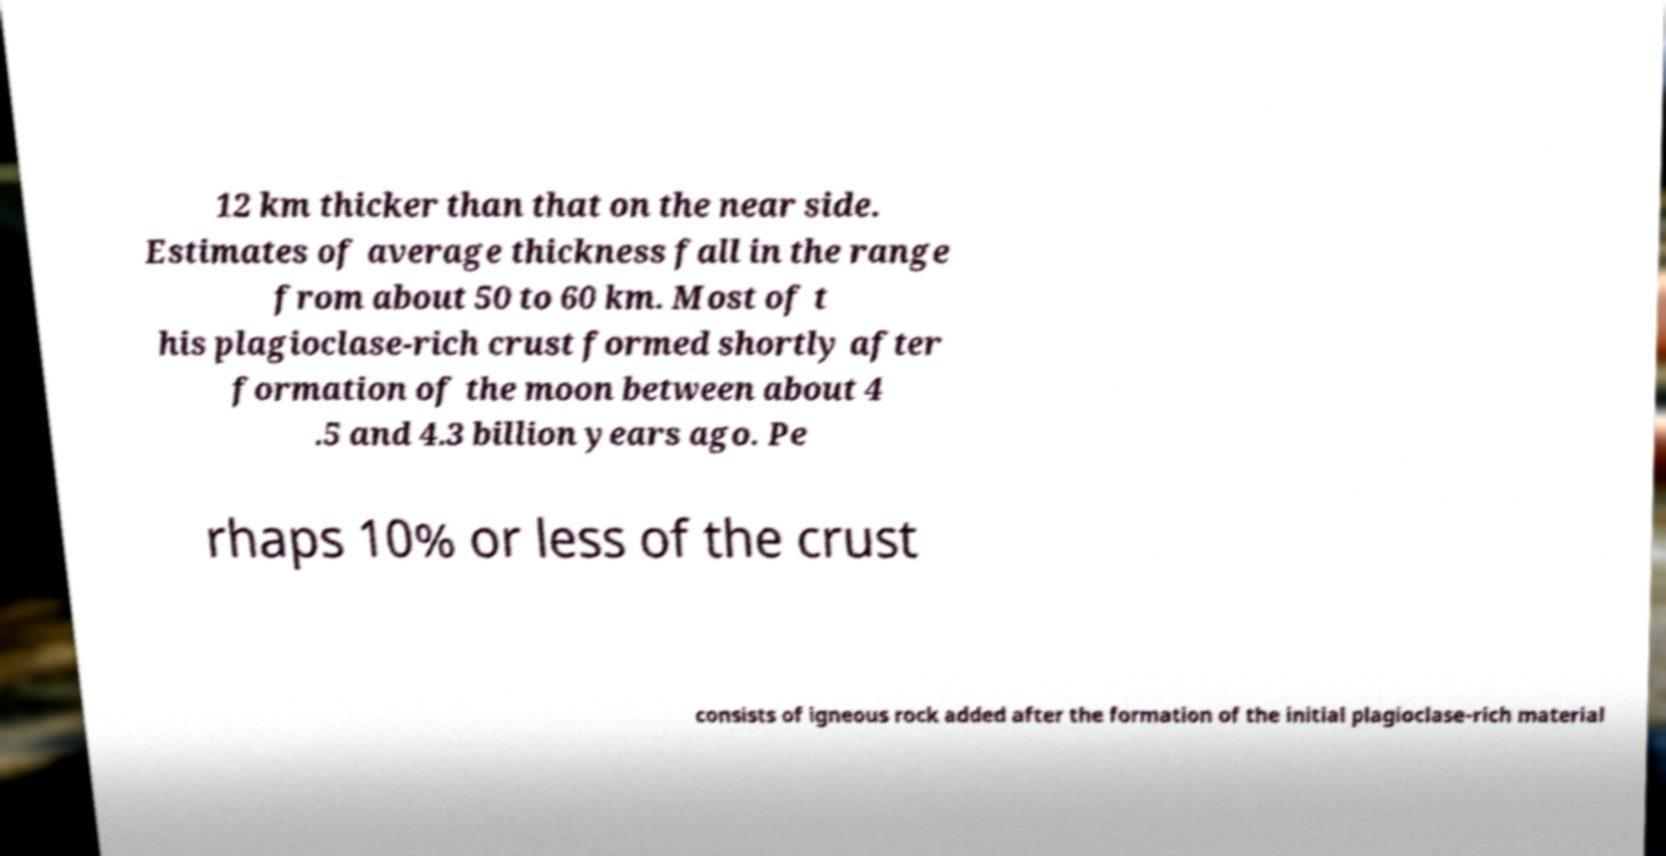There's text embedded in this image that I need extracted. Can you transcribe it verbatim? 12 km thicker than that on the near side. Estimates of average thickness fall in the range from about 50 to 60 km. Most of t his plagioclase-rich crust formed shortly after formation of the moon between about 4 .5 and 4.3 billion years ago. Pe rhaps 10% or less of the crust consists of igneous rock added after the formation of the initial plagioclase-rich material 